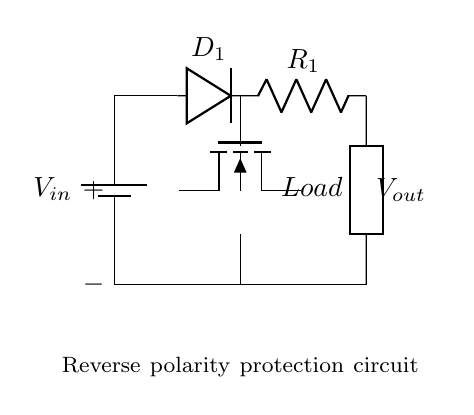What type of protection does this circuit provide? This circuit provides reverse polarity protection by using a diode (D1) that allows current to flow only when the voltage is connected correctly. If the polarity is reversed, the diode will block current flow, protecting the load.
Answer: Reverse polarity protection What is the role of D1 in this circuit? D1, the diode, allows current to pass through the circuit only when the voltage is connected in the correct orientation. When the polarity is reversed, it becomes reverse-biased and prevents current from flowing, thus protecting the circuit.
Answer: To block reverse current What component limits the current flow after D1? The component limiting the current flow after D1 is the resistor R1. It regulates the amount of current that can flow to the load.
Answer: Resistor What happens if the input voltage is reversed? If the input voltage is reversed, the diode D1 will be reverse-biased and will not conduct, effectively disconnecting the load from the power source and protecting it from damage.
Answer: No current flows What is the function of the NFET in this circuit? The function of the NFET in this circuit is to act as a switch that can control the current for the load based on the voltage polarity. However, it does not engage until the correct polarity is applied, contributing to the protection mechanism.
Answer: Acts as a switch What is the expected output voltage when the circuit is connected correctly? The expected output voltage when the circuit is connected correctly is the same as the input voltage, assuming the diode's forward voltage drop is negligible.
Answer: V in 